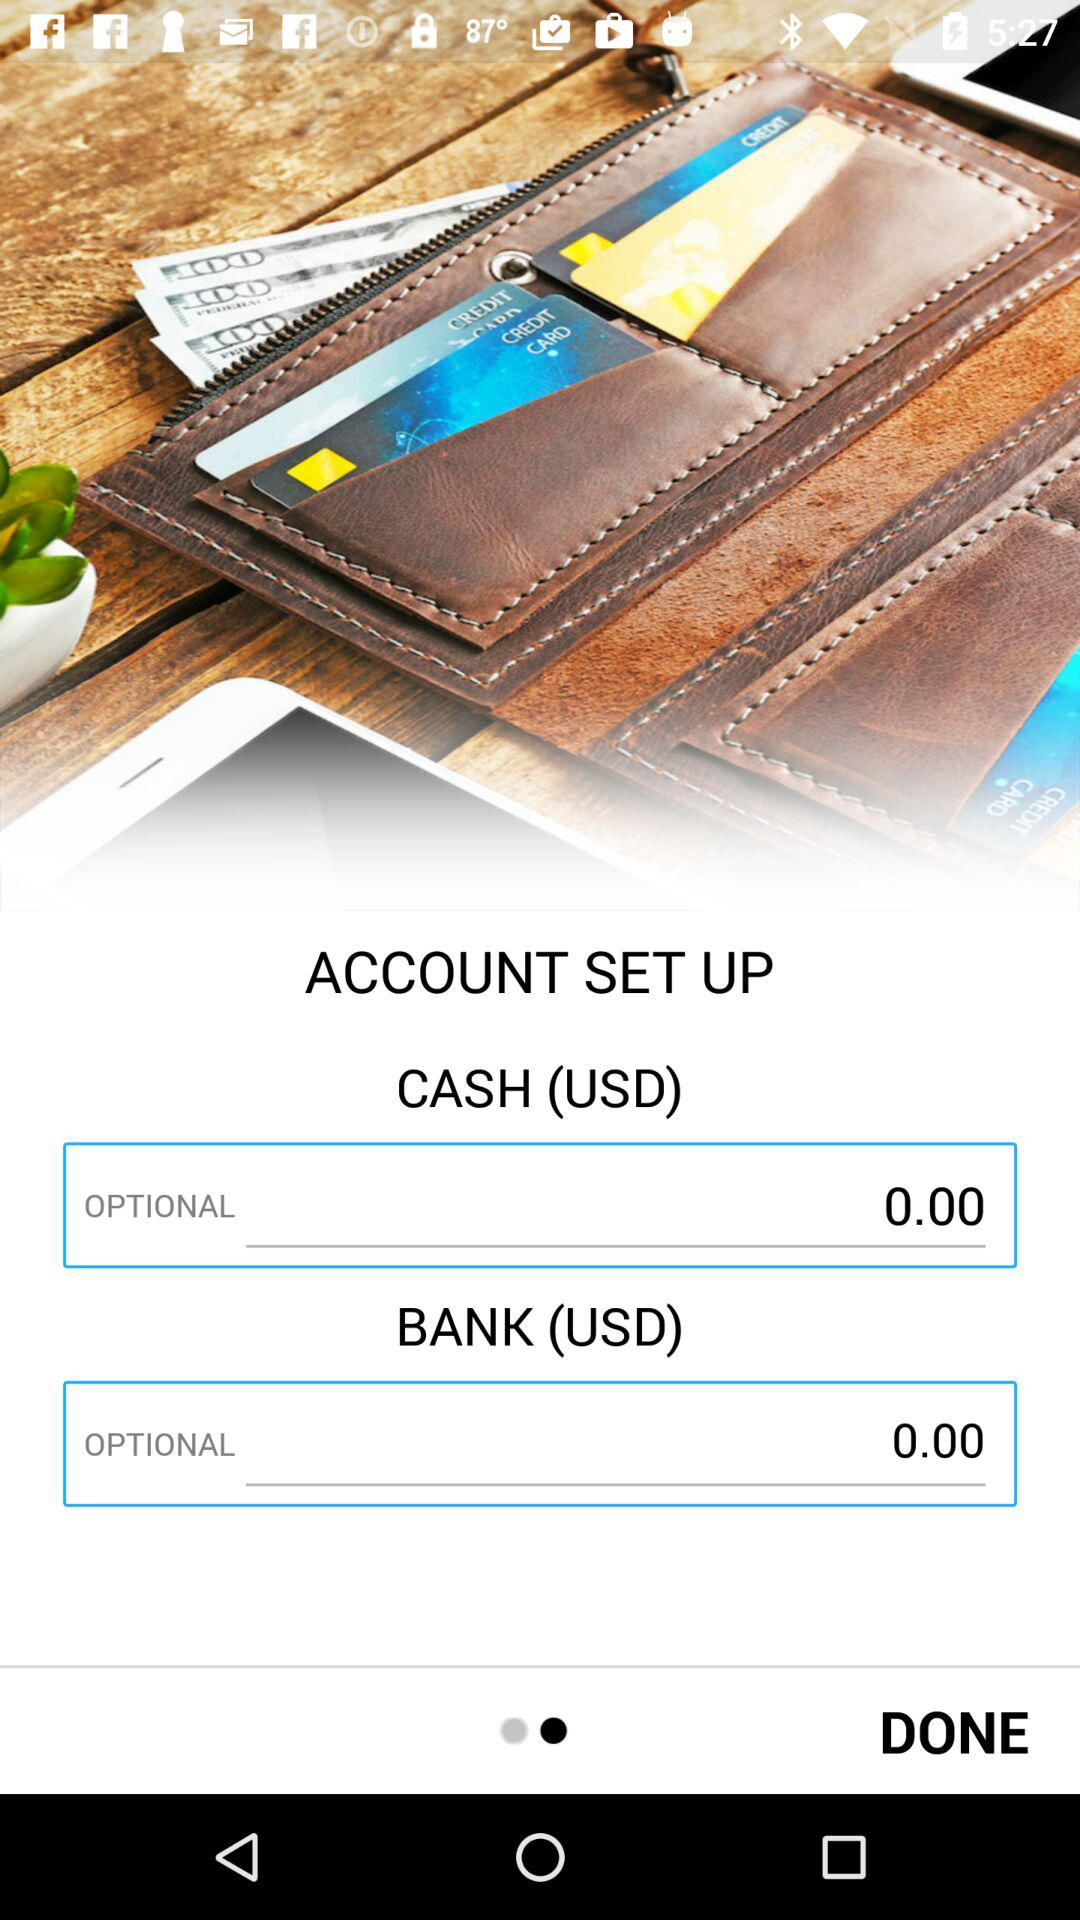How many optional fields are there?
Answer the question using a single word or phrase. 2 